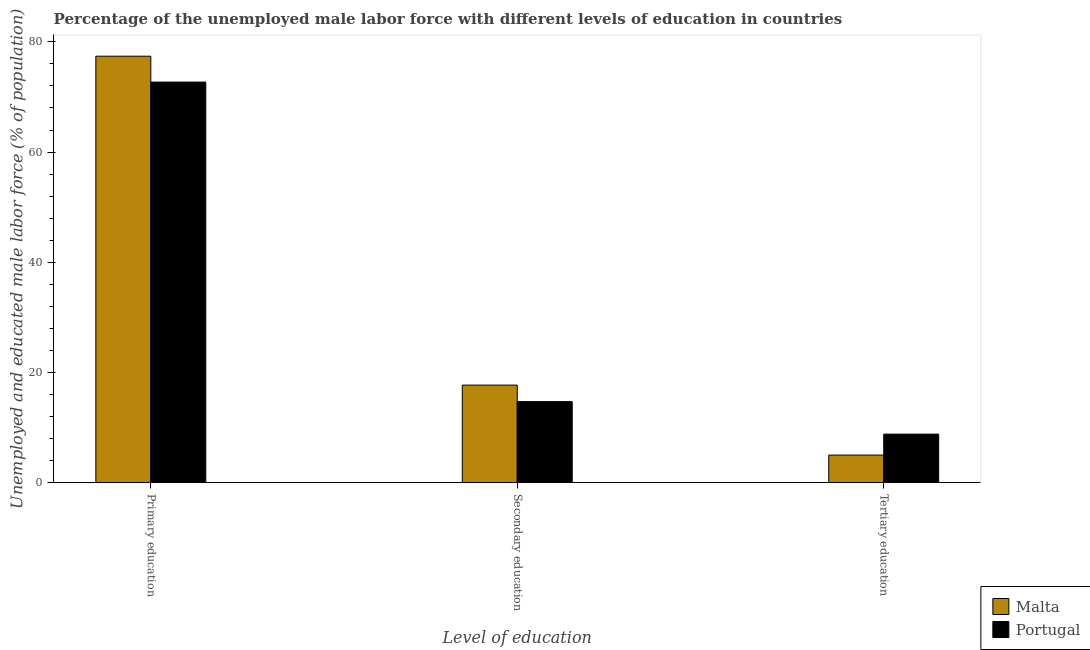How many different coloured bars are there?
Provide a short and direct response. 2. How many groups of bars are there?
Ensure brevity in your answer.  3. How many bars are there on the 2nd tick from the left?
Ensure brevity in your answer.  2. What is the label of the 2nd group of bars from the left?
Offer a very short reply. Secondary education. What is the percentage of male labor force who received tertiary education in Portugal?
Your answer should be very brief. 8.8. Across all countries, what is the maximum percentage of male labor force who received primary education?
Offer a very short reply. 77.4. Across all countries, what is the minimum percentage of male labor force who received secondary education?
Ensure brevity in your answer.  14.7. In which country was the percentage of male labor force who received tertiary education maximum?
Keep it short and to the point. Portugal. What is the total percentage of male labor force who received secondary education in the graph?
Ensure brevity in your answer.  32.4. What is the difference between the percentage of male labor force who received secondary education in Portugal and that in Malta?
Provide a short and direct response. -3. What is the difference between the percentage of male labor force who received primary education in Portugal and the percentage of male labor force who received secondary education in Malta?
Make the answer very short. 55. What is the average percentage of male labor force who received tertiary education per country?
Give a very brief answer. 6.9. What is the difference between the percentage of male labor force who received secondary education and percentage of male labor force who received tertiary education in Portugal?
Provide a short and direct response. 5.9. In how many countries, is the percentage of male labor force who received secondary education greater than 72 %?
Offer a very short reply. 0. What is the ratio of the percentage of male labor force who received primary education in Malta to that in Portugal?
Make the answer very short. 1.06. What is the difference between the highest and the second highest percentage of male labor force who received secondary education?
Offer a terse response. 3. What is the difference between the highest and the lowest percentage of male labor force who received tertiary education?
Keep it short and to the point. 3.8. In how many countries, is the percentage of male labor force who received secondary education greater than the average percentage of male labor force who received secondary education taken over all countries?
Keep it short and to the point. 1. Is the sum of the percentage of male labor force who received primary education in Portugal and Malta greater than the maximum percentage of male labor force who received tertiary education across all countries?
Keep it short and to the point. Yes. What does the 2nd bar from the left in Tertiary education represents?
Your response must be concise. Portugal. How many bars are there?
Provide a short and direct response. 6. Are all the bars in the graph horizontal?
Offer a terse response. No. How are the legend labels stacked?
Offer a very short reply. Vertical. What is the title of the graph?
Your answer should be very brief. Percentage of the unemployed male labor force with different levels of education in countries. Does "Grenada" appear as one of the legend labels in the graph?
Your answer should be very brief. No. What is the label or title of the X-axis?
Ensure brevity in your answer.  Level of education. What is the label or title of the Y-axis?
Offer a very short reply. Unemployed and educated male labor force (% of population). What is the Unemployed and educated male labor force (% of population) in Malta in Primary education?
Make the answer very short. 77.4. What is the Unemployed and educated male labor force (% of population) of Portugal in Primary education?
Make the answer very short. 72.7. What is the Unemployed and educated male labor force (% of population) of Malta in Secondary education?
Your answer should be very brief. 17.7. What is the Unemployed and educated male labor force (% of population) of Portugal in Secondary education?
Provide a short and direct response. 14.7. What is the Unemployed and educated male labor force (% of population) of Malta in Tertiary education?
Your answer should be compact. 5. What is the Unemployed and educated male labor force (% of population) in Portugal in Tertiary education?
Make the answer very short. 8.8. Across all Level of education, what is the maximum Unemployed and educated male labor force (% of population) in Malta?
Give a very brief answer. 77.4. Across all Level of education, what is the maximum Unemployed and educated male labor force (% of population) in Portugal?
Your response must be concise. 72.7. Across all Level of education, what is the minimum Unemployed and educated male labor force (% of population) of Portugal?
Your answer should be compact. 8.8. What is the total Unemployed and educated male labor force (% of population) of Malta in the graph?
Your answer should be compact. 100.1. What is the total Unemployed and educated male labor force (% of population) in Portugal in the graph?
Your answer should be compact. 96.2. What is the difference between the Unemployed and educated male labor force (% of population) in Malta in Primary education and that in Secondary education?
Your response must be concise. 59.7. What is the difference between the Unemployed and educated male labor force (% of population) in Malta in Primary education and that in Tertiary education?
Your response must be concise. 72.4. What is the difference between the Unemployed and educated male labor force (% of population) in Portugal in Primary education and that in Tertiary education?
Give a very brief answer. 63.9. What is the difference between the Unemployed and educated male labor force (% of population) in Malta in Secondary education and that in Tertiary education?
Ensure brevity in your answer.  12.7. What is the difference between the Unemployed and educated male labor force (% of population) of Portugal in Secondary education and that in Tertiary education?
Give a very brief answer. 5.9. What is the difference between the Unemployed and educated male labor force (% of population) of Malta in Primary education and the Unemployed and educated male labor force (% of population) of Portugal in Secondary education?
Your answer should be compact. 62.7. What is the difference between the Unemployed and educated male labor force (% of population) in Malta in Primary education and the Unemployed and educated male labor force (% of population) in Portugal in Tertiary education?
Ensure brevity in your answer.  68.6. What is the average Unemployed and educated male labor force (% of population) in Malta per Level of education?
Provide a short and direct response. 33.37. What is the average Unemployed and educated male labor force (% of population) in Portugal per Level of education?
Make the answer very short. 32.07. What is the difference between the Unemployed and educated male labor force (% of population) in Malta and Unemployed and educated male labor force (% of population) in Portugal in Tertiary education?
Your answer should be compact. -3.8. What is the ratio of the Unemployed and educated male labor force (% of population) of Malta in Primary education to that in Secondary education?
Ensure brevity in your answer.  4.37. What is the ratio of the Unemployed and educated male labor force (% of population) of Portugal in Primary education to that in Secondary education?
Provide a succinct answer. 4.95. What is the ratio of the Unemployed and educated male labor force (% of population) in Malta in Primary education to that in Tertiary education?
Provide a short and direct response. 15.48. What is the ratio of the Unemployed and educated male labor force (% of population) of Portugal in Primary education to that in Tertiary education?
Offer a terse response. 8.26. What is the ratio of the Unemployed and educated male labor force (% of population) in Malta in Secondary education to that in Tertiary education?
Make the answer very short. 3.54. What is the ratio of the Unemployed and educated male labor force (% of population) in Portugal in Secondary education to that in Tertiary education?
Ensure brevity in your answer.  1.67. What is the difference between the highest and the second highest Unemployed and educated male labor force (% of population) of Malta?
Your answer should be compact. 59.7. What is the difference between the highest and the second highest Unemployed and educated male labor force (% of population) in Portugal?
Ensure brevity in your answer.  58. What is the difference between the highest and the lowest Unemployed and educated male labor force (% of population) in Malta?
Keep it short and to the point. 72.4. What is the difference between the highest and the lowest Unemployed and educated male labor force (% of population) in Portugal?
Offer a very short reply. 63.9. 